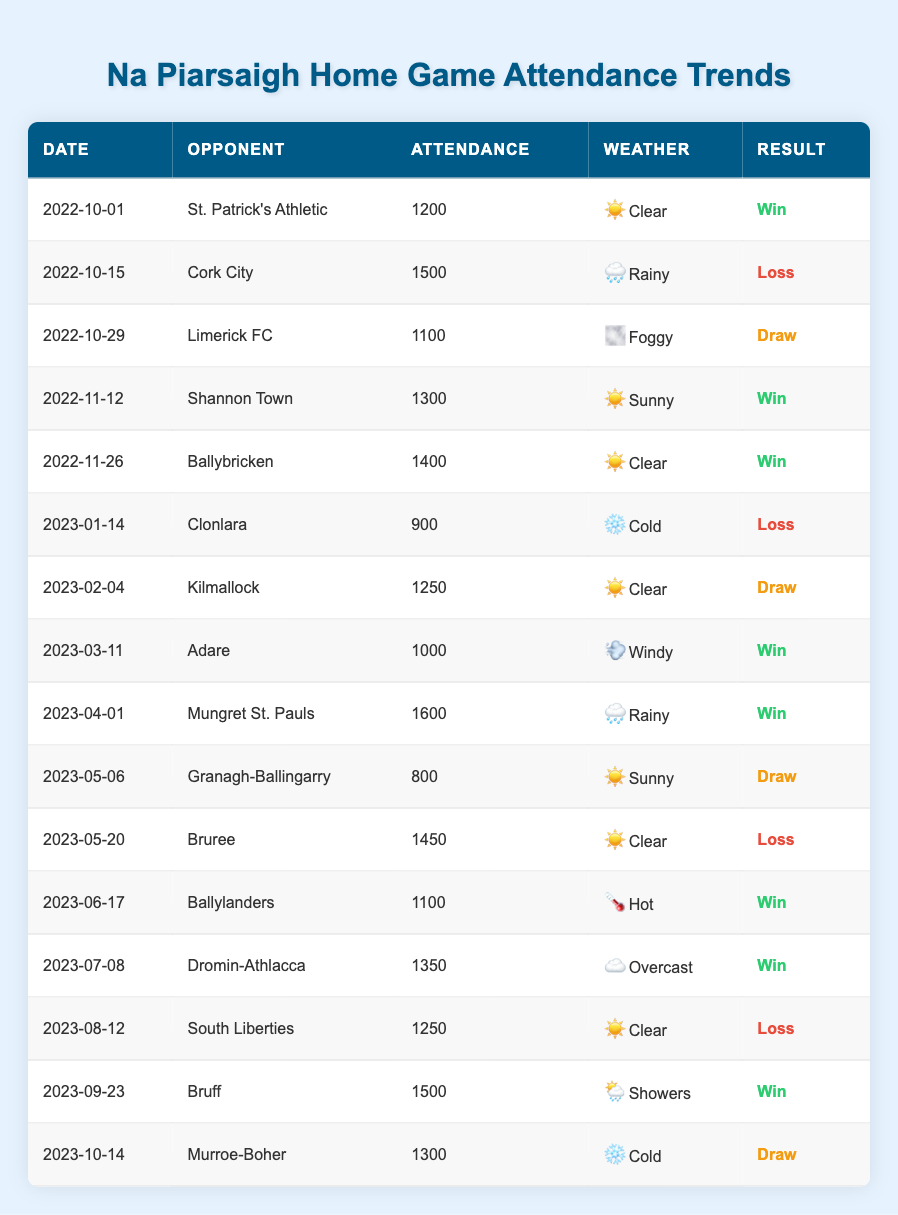What was the attendance for the game against Clonlara? The table indicates that the attendance for the game on January 14, 2023, against Clonlara was 900.
Answer: 900 How many games resulted in a draw? By counting the instances where the result is noted as "Draw" in the Result column, we find that there are three games (2022-10-29, 2023-02-04, 2023-10-14) that ended in a draw.
Answer: 3 What was the maximum attendance at home games in the last year? Looking at the attendance values listed, the highest attendance recorded was 1600 during the game against Mungret St. Pauls on April 1, 2023.
Answer: 1600 Was there more than one game played during rainy weather? The table shows that there were three games classified under the weather condition "Rainy" (2022-10-15, 2023-04-01, 2023-05-06). Since this number is greater than one, the answer is yes.
Answer: Yes What is the total attendance from all home games? To find the total attendance, we add up all attendance figures: 1200 + 1500 + 1100 + 1300 + 1400 + 900 + 1250 + 1000 + 1600 + 800 + 1450 + 1100 + 1350 + 1250 + 1500 + 1300 = 18700.
Answer: 18700 How many games did Na Piarsaigh win after a clear weather day? By reviewing the Wins aligned with "Clear" weather conditions, we see they won four games (2022-10-01, 2022-11-26, 2023-02-04, 2023-05-20).
Answer: 4 What was the average attendance for games that resulted in a loss? The attendances for games lost are 1500, 900, 1450, and 1250. We calculate the average as (1500 + 900 + 1450 + 1250) / 4 = 1040. The total attendance for losses is 5100, which divided by 4 gives an average of 1275.
Answer: 1275 Did Na Piarsaigh score more wins in hot or cold weather? In total, Na Piarsaigh won three games while playing in hot weather (1100) and two games in cold weather (900). Therefore, more wins occurred in hot weather.
Answer: Hot weather What is the total number of matches played in overcast conditions? There was 1 match played under "Overcast" conditions on July 8, 2023 against Dromin-Athlacca, confirming that there was only one such match.
Answer: 1 